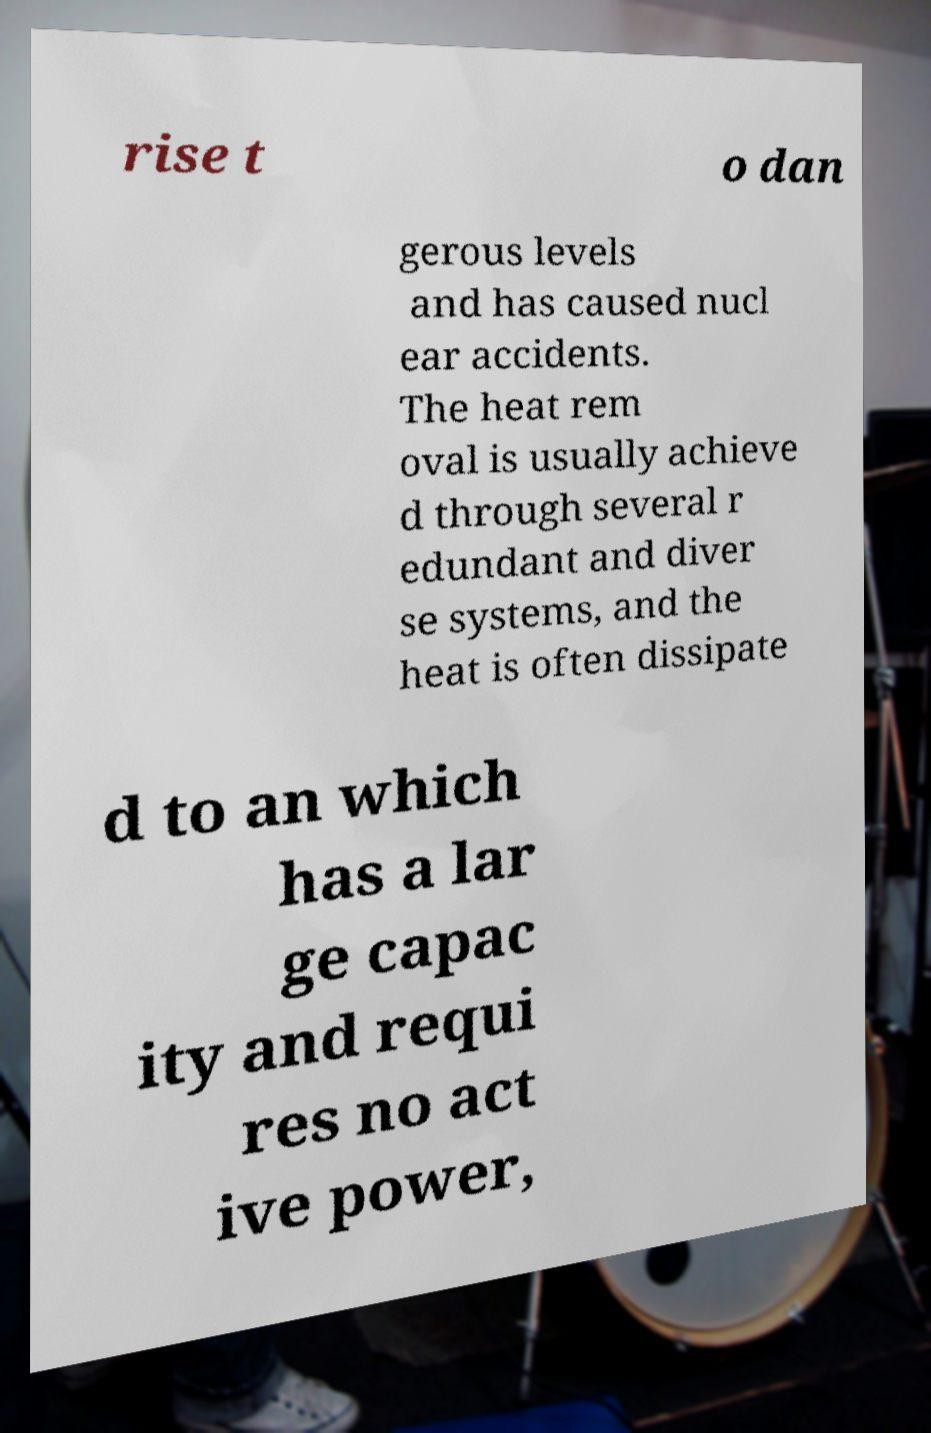For documentation purposes, I need the text within this image transcribed. Could you provide that? rise t o dan gerous levels and has caused nucl ear accidents. The heat rem oval is usually achieve d through several r edundant and diver se systems, and the heat is often dissipate d to an which has a lar ge capac ity and requi res no act ive power, 